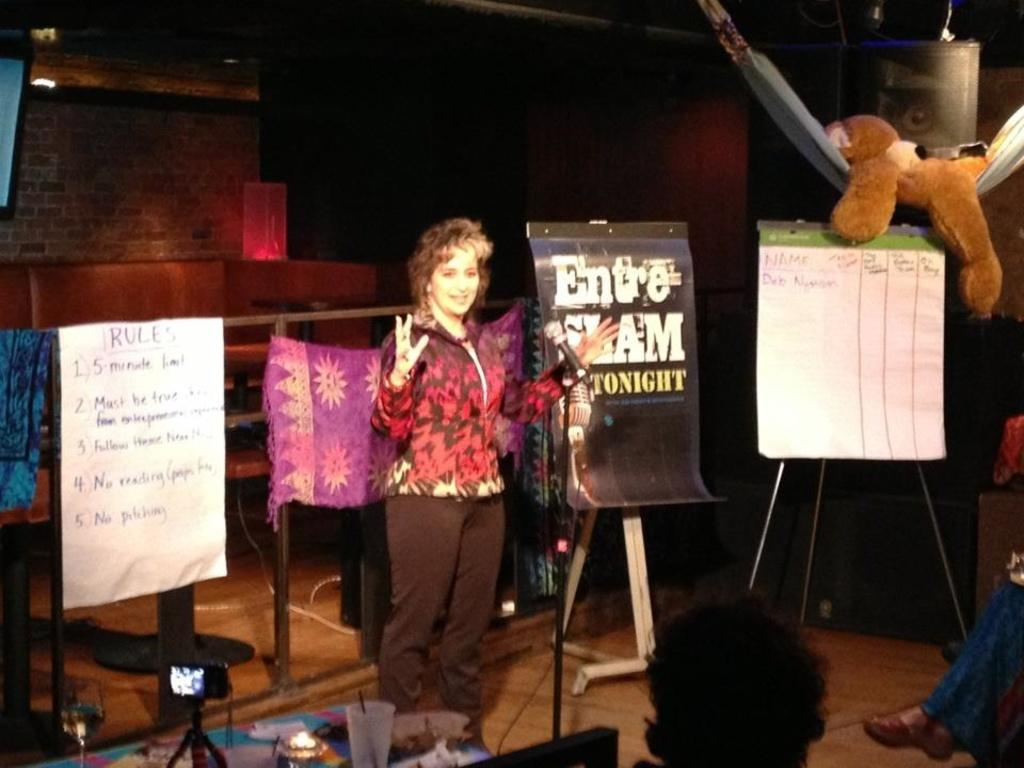What is the main subject of the image? There is a woman standing in the image. Where is the woman standing? The woman is standing on the floor. What other objects can be seen in the image? There is a table in the image. What is on the table? There is a glass on the table. How many corks are on the table in the image? There are no corks present on the table in the image. What type of dolls can be seen playing with the glass in the image? There are no dolls present in the image, and the glass is not being played with. 